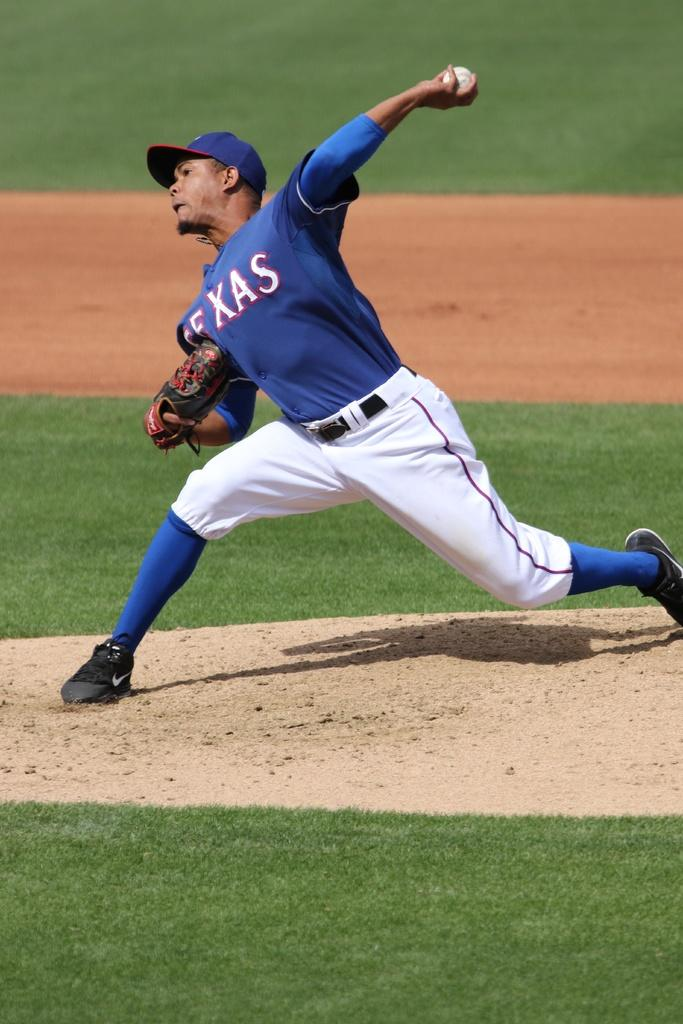<image>
Present a compact description of the photo's key features. a Texas player getting ready to throw the ball 